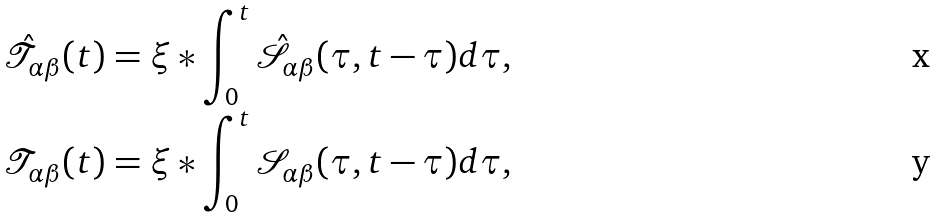Convert formula to latex. <formula><loc_0><loc_0><loc_500><loc_500>\mathcal { \hat { T } } _ { \alpha \beta } ( t ) & = \xi * \int _ { 0 } ^ { t } \hat { \mathcal { S } } _ { \alpha \beta } ( \tau , t - \tau ) d \tau , \\ \mathcal { T } _ { \alpha \beta } ( t ) & = \xi * \int _ { 0 } ^ { t } \mathcal { S } _ { \alpha \beta } ( \tau , t - \tau ) d \tau ,</formula> 